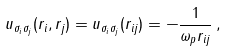<formula> <loc_0><loc_0><loc_500><loc_500>u _ { \sigma _ { i } \sigma _ { j } } ( { r } _ { i } , { r } _ { j } ) = u _ { \sigma _ { i } \sigma _ { j } } ( r _ { i j } ) = - \frac { 1 } { \omega _ { p } r _ { i j } } \, ,</formula> 